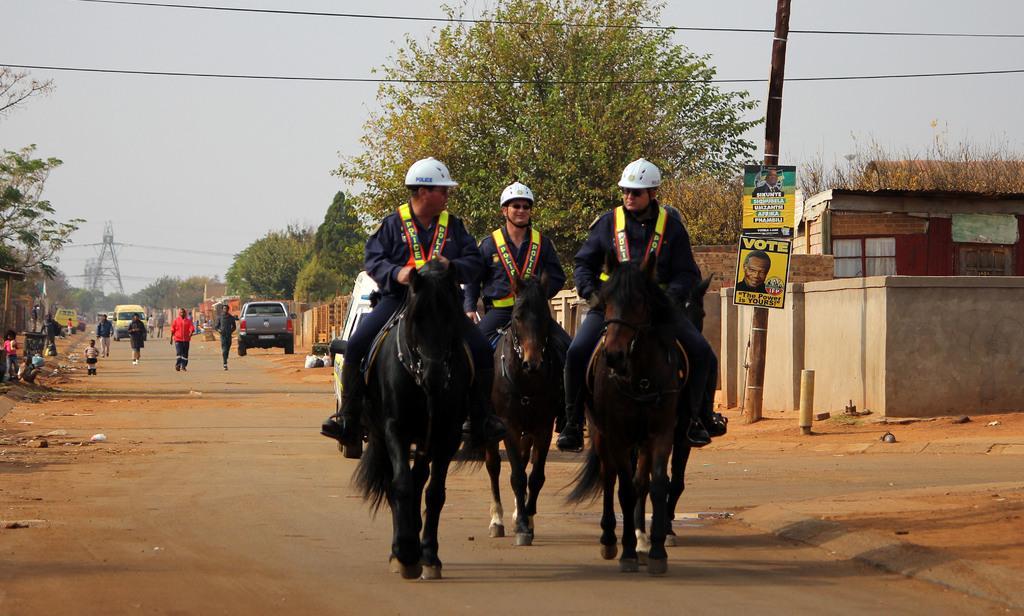Could you give a brief overview of what you see in this image? This image consists of three horses on which there are three men wearing blue dresses are riding. At the bottom, there is a road. In the background, there are trees. And we can see many people and cars on the road. At the top, there is sky. 